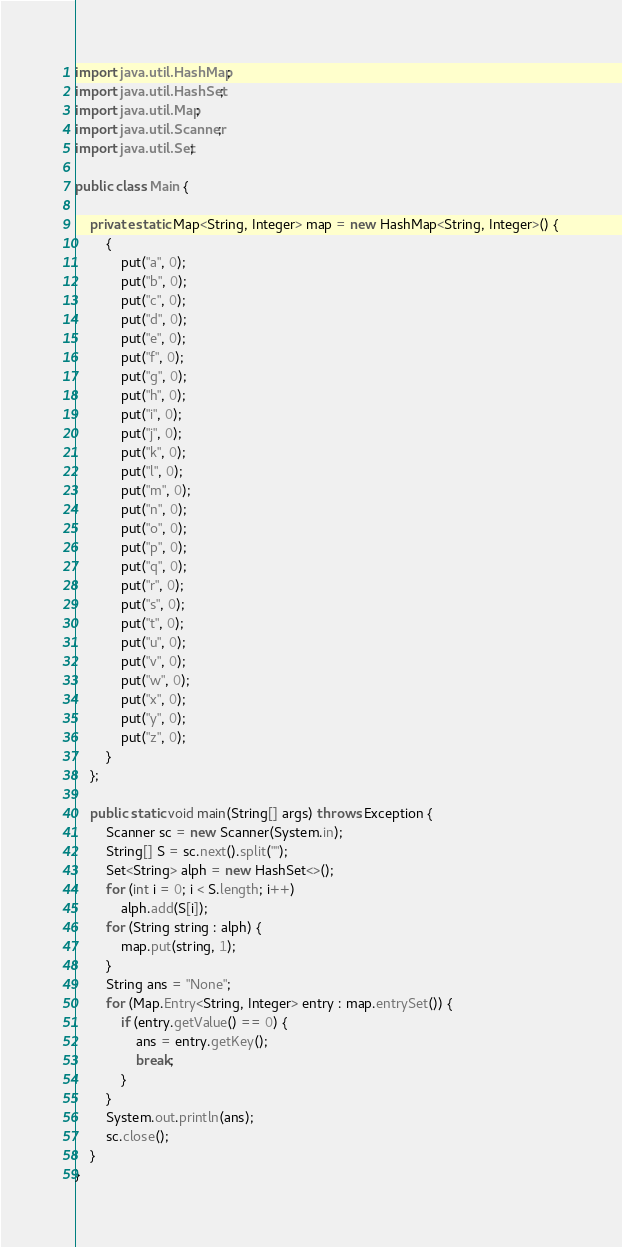<code> <loc_0><loc_0><loc_500><loc_500><_Java_>import java.util.HashMap;
import java.util.HashSet;
import java.util.Map;
import java.util.Scanner;
import java.util.Set;

public class Main {

	private static Map<String, Integer> map = new HashMap<String, Integer>() {
		{
			put("a", 0);
			put("b", 0);
			put("c", 0);
			put("d", 0);
			put("e", 0);
			put("f", 0);
			put("g", 0);
			put("h", 0);
			put("i", 0);
			put("j", 0);
			put("k", 0);
			put("l", 0);
			put("m", 0);
			put("n", 0);
			put("o", 0);
			put("p", 0);
			put("q", 0);
			put("r", 0);
			put("s", 0);
			put("t", 0);
			put("u", 0);
			put("v", 0);
			put("w", 0);
			put("x", 0);
			put("y", 0);
			put("z", 0);
		}
	};

	public static void main(String[] args) throws Exception {
		Scanner sc = new Scanner(System.in);
		String[] S = sc.next().split("");
		Set<String> alph = new HashSet<>();
		for (int i = 0; i < S.length; i++)
			alph.add(S[i]);
		for (String string : alph) {
			map.put(string, 1);
		}
		String ans = "None";
		for (Map.Entry<String, Integer> entry : map.entrySet()) {
			if (entry.getValue() == 0) {
				ans = entry.getKey();
				break;
			}
		}
		System.out.println(ans);
		sc.close();
	}
}</code> 